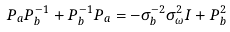Convert formula to latex. <formula><loc_0><loc_0><loc_500><loc_500>P _ { a } P _ { b } ^ { - 1 } + P _ { b } ^ { - 1 } P _ { a } = - \sigma _ { b } ^ { - 2 } \sigma _ { \omega } ^ { 2 } I + P _ { b } ^ { 2 }</formula> 